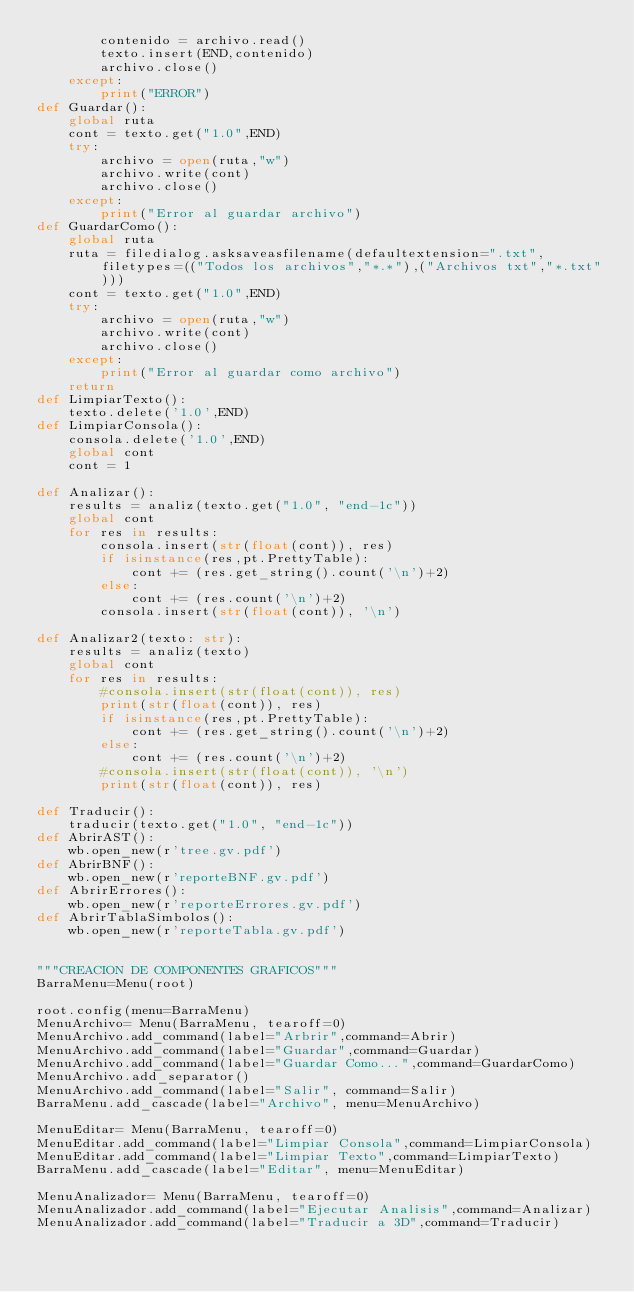<code> <loc_0><loc_0><loc_500><loc_500><_Python_>        contenido = archivo.read()
        texto.insert(END,contenido)
        archivo.close()
    except:
        print("ERROR")
def Guardar():
    global ruta
    cont = texto.get("1.0",END)
    try:
        archivo = open(ruta,"w")
        archivo.write(cont)
        archivo.close()
    except:
        print("Error al guardar archivo")
def GuardarComo():
    global ruta
    ruta = filedialog.asksaveasfilename(defaultextension=".txt", filetypes=(("Todos los archivos","*.*"),("Archivos txt","*.txt")))
    cont = texto.get("1.0",END)
    try:
        archivo = open(ruta,"w")
        archivo.write(cont)
        archivo.close()
    except:
        print("Error al guardar como archivo")
    return
def LimpiarTexto():
    texto.delete('1.0',END)
def LimpiarConsola():
    consola.delete('1.0',END)
    global cont
    cont = 1

def Analizar():
    results = analiz(texto.get("1.0", "end-1c"))
    global cont
    for res in results:
        consola.insert(str(float(cont)), res)
        if isinstance(res,pt.PrettyTable):
            cont += (res.get_string().count('\n')+2)
        else:
            cont += (res.count('\n')+2)
        consola.insert(str(float(cont)), '\n')

def Analizar2(texto: str):
    results = analiz(texto)
    global cont
    for res in results:
        #consola.insert(str(float(cont)), res)
        print(str(float(cont)), res)
        if isinstance(res,pt.PrettyTable):
            cont += (res.get_string().count('\n')+2)
        else:
            cont += (res.count('\n')+2)
        #consola.insert(str(float(cont)), '\n')
        print(str(float(cont)), res)

def Traducir():
    traducir(texto.get("1.0", "end-1c"))
def AbrirAST():
    wb.open_new(r'tree.gv.pdf')
def AbrirBNF():
    wb.open_new(r'reporteBNF.gv.pdf')
def AbrirErrores():
    wb.open_new(r'reporteErrores.gv.pdf')
def AbrirTablaSimbolos():
    wb.open_new(r'reporteTabla.gv.pdf')


"""CREACION DE COMPONENTES GRAFICOS"""
BarraMenu=Menu(root)

root.config(menu=BarraMenu)
MenuArchivo= Menu(BarraMenu, tearoff=0)
MenuArchivo.add_command(label="Arbrir",command=Abrir)
MenuArchivo.add_command(label="Guardar",command=Guardar)
MenuArchivo.add_command(label="Guardar Como...",command=GuardarComo)
MenuArchivo.add_separator()
MenuArchivo.add_command(label="Salir", command=Salir)
BarraMenu.add_cascade(label="Archivo", menu=MenuArchivo)

MenuEditar= Menu(BarraMenu, tearoff=0)
MenuEditar.add_command(label="Limpiar Consola",command=LimpiarConsola)
MenuEditar.add_command(label="Limpiar Texto",command=LimpiarTexto)
BarraMenu.add_cascade(label="Editar", menu=MenuEditar)

MenuAnalizador= Menu(BarraMenu, tearoff=0)
MenuAnalizador.add_command(label="Ejecutar Analisis",command=Analizar)
MenuAnalizador.add_command(label="Traducir a 3D",command=Traducir)</code> 